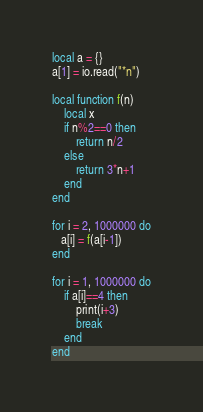<code> <loc_0><loc_0><loc_500><loc_500><_Lua_>local a = {}
a[1] = io.read("*n")

local function f(n)
    local x
    if n%2==0 then
        return n/2
    else
        return 3*n+1
    end
end

for i = 2, 1000000 do
   a[i] = f(a[i-1])
end

for i = 1, 1000000 do
    if a[i]==4 then
        print(i+3)
        break
    end
end</code> 